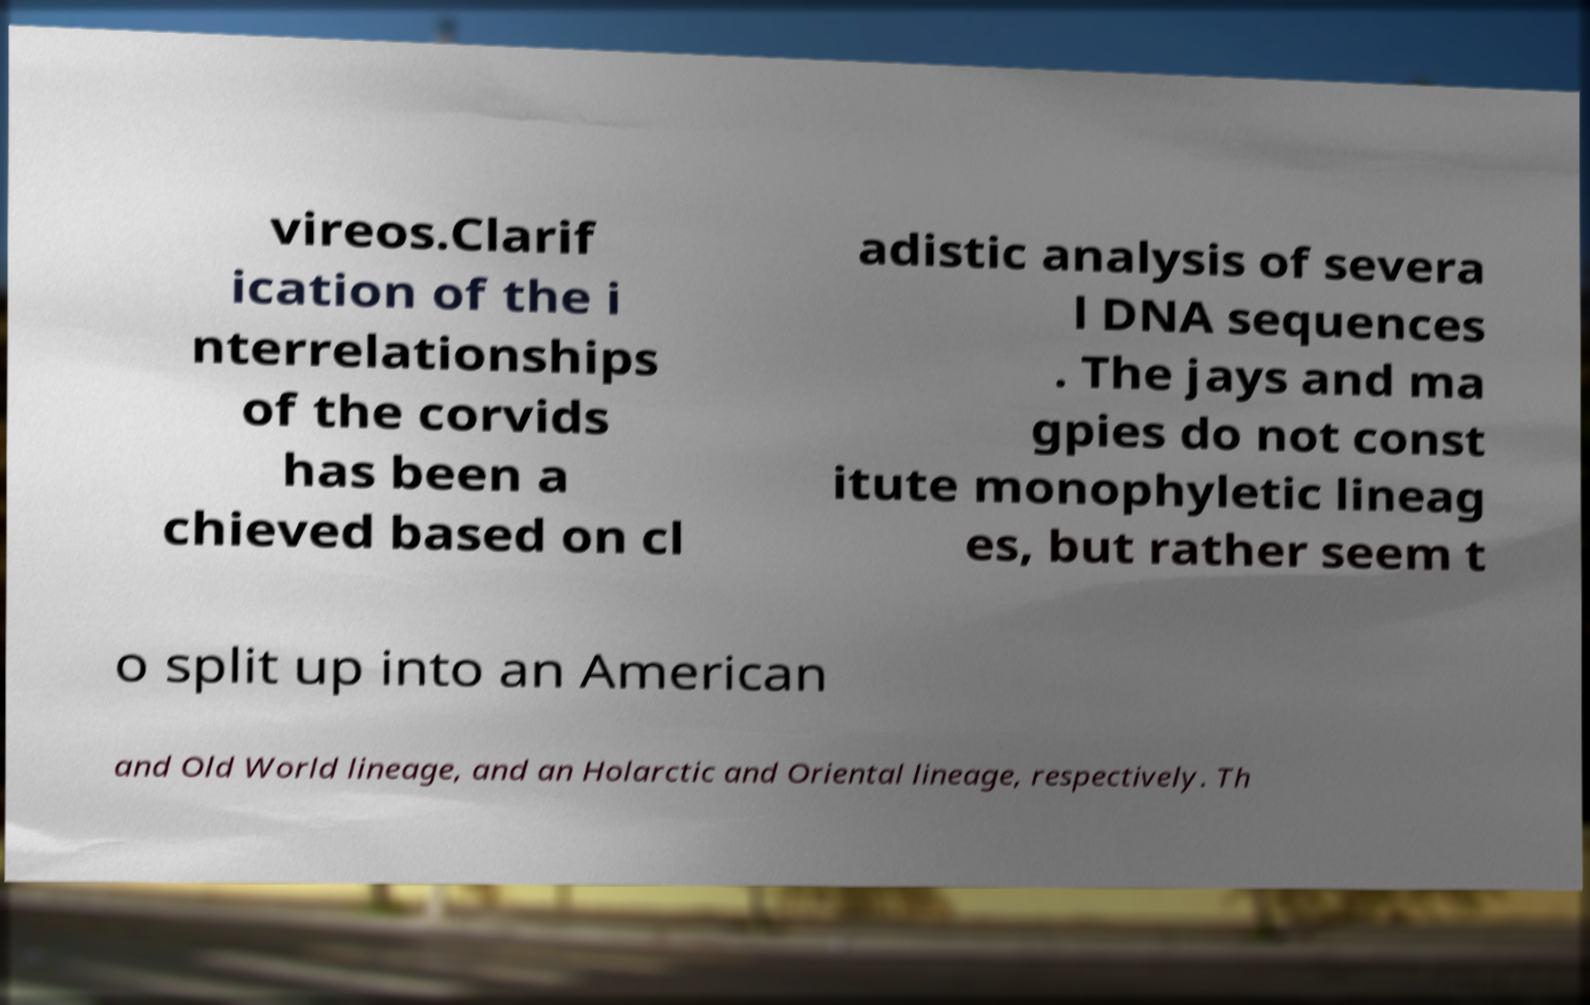Could you assist in decoding the text presented in this image and type it out clearly? vireos.Clarif ication of the i nterrelationships of the corvids has been a chieved based on cl adistic analysis of severa l DNA sequences . The jays and ma gpies do not const itute monophyletic lineag es, but rather seem t o split up into an American and Old World lineage, and an Holarctic and Oriental lineage, respectively. Th 